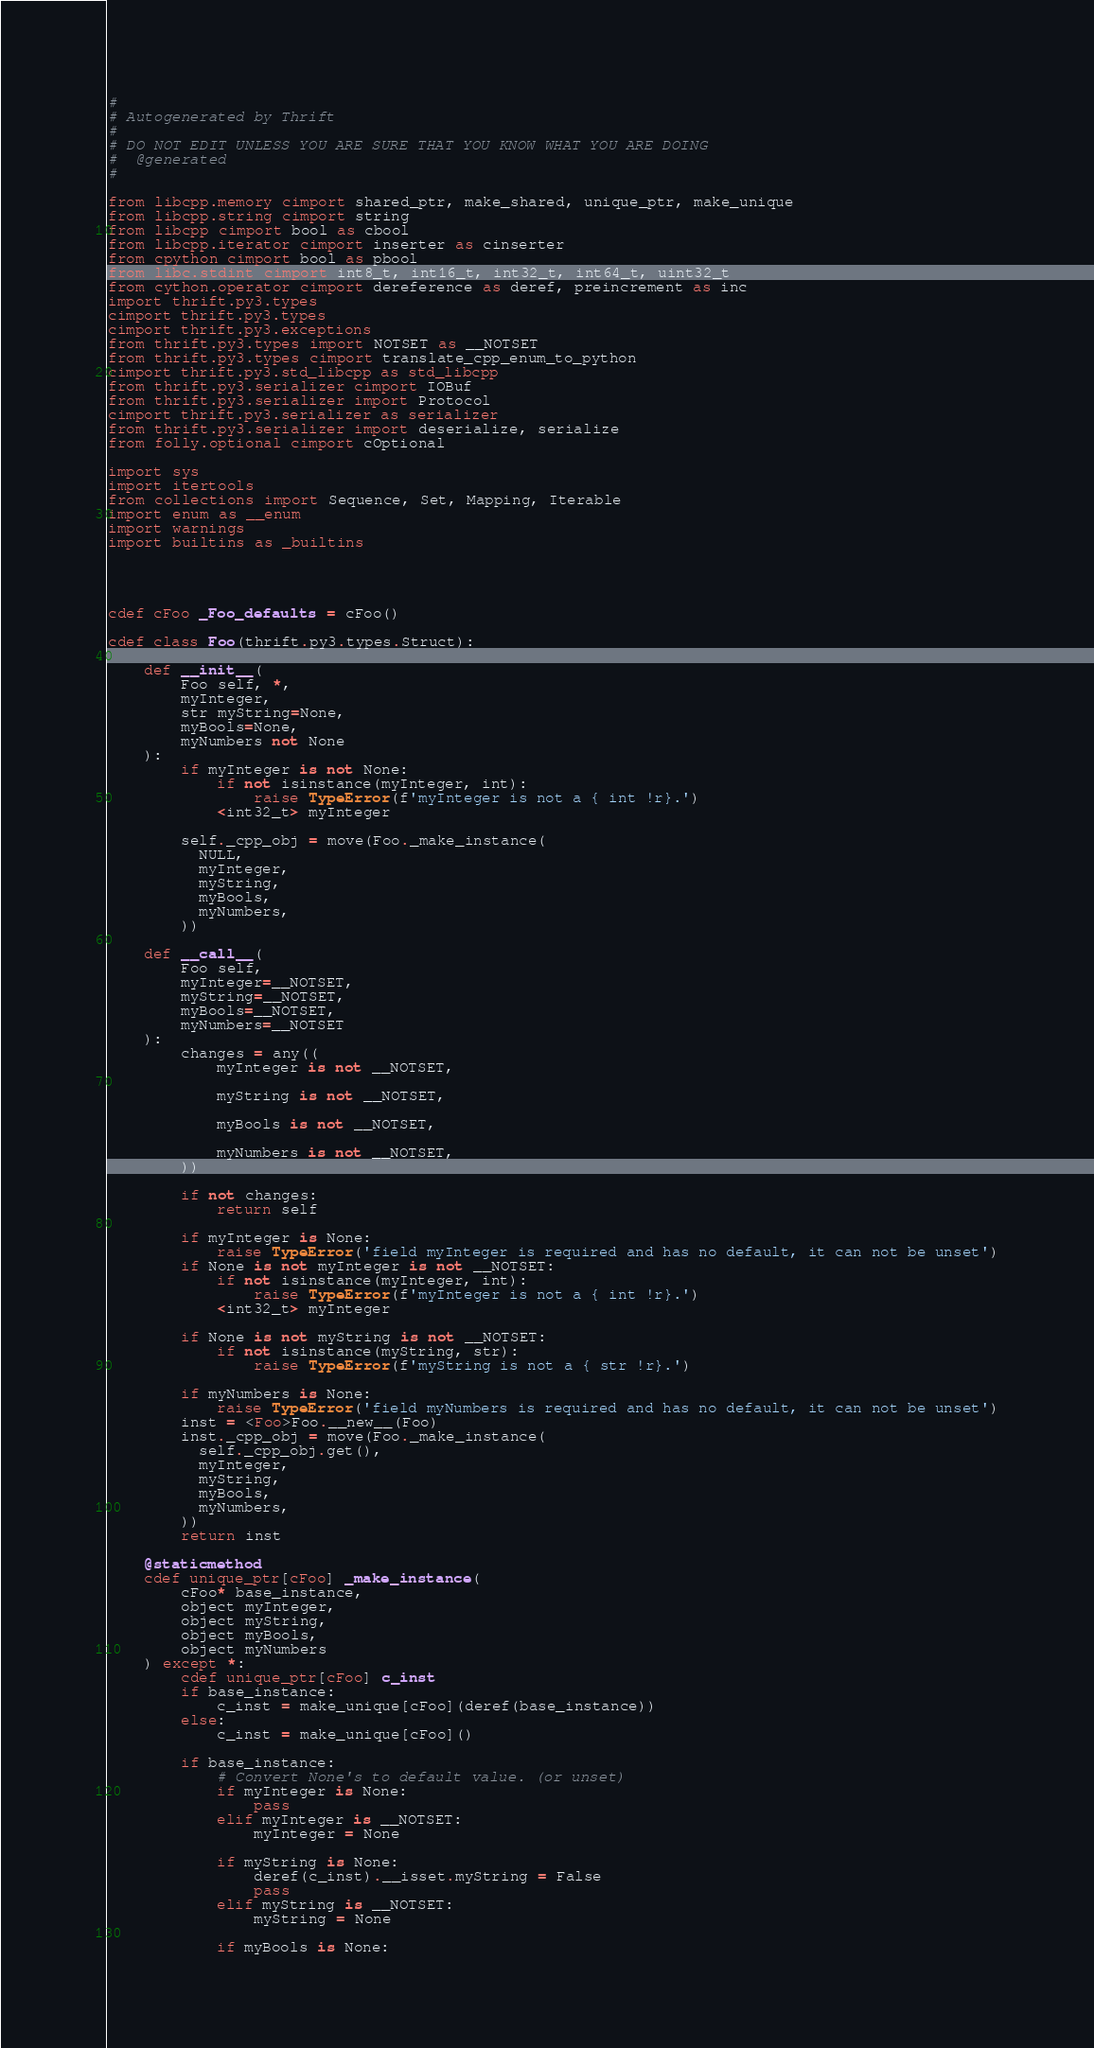<code> <loc_0><loc_0><loc_500><loc_500><_Cython_>#
# Autogenerated by Thrift
#
# DO NOT EDIT UNLESS YOU ARE SURE THAT YOU KNOW WHAT YOU ARE DOING
#  @generated
#

from libcpp.memory cimport shared_ptr, make_shared, unique_ptr, make_unique
from libcpp.string cimport string
from libcpp cimport bool as cbool
from libcpp.iterator cimport inserter as cinserter
from cpython cimport bool as pbool
from libc.stdint cimport int8_t, int16_t, int32_t, int64_t, uint32_t
from cython.operator cimport dereference as deref, preincrement as inc
import thrift.py3.types
cimport thrift.py3.types
cimport thrift.py3.exceptions
from thrift.py3.types import NOTSET as __NOTSET
from thrift.py3.types cimport translate_cpp_enum_to_python
cimport thrift.py3.std_libcpp as std_libcpp
from thrift.py3.serializer cimport IOBuf
from thrift.py3.serializer import Protocol
cimport thrift.py3.serializer as serializer
from thrift.py3.serializer import deserialize, serialize
from folly.optional cimport cOptional

import sys
import itertools
from collections import Sequence, Set, Mapping, Iterable
import enum as __enum
import warnings
import builtins as _builtins




cdef cFoo _Foo_defaults = cFoo()

cdef class Foo(thrift.py3.types.Struct):

    def __init__(
        Foo self, *,
        myInteger,
        str myString=None,
        myBools=None,
        myNumbers not None
    ):
        if myInteger is not None:
            if not isinstance(myInteger, int):
                raise TypeError(f'myInteger is not a { int !r}.')
            <int32_t> myInteger

        self._cpp_obj = move(Foo._make_instance(
          NULL,
          myInteger,
          myString,
          myBools,
          myNumbers,
        ))

    def __call__(
        Foo self,
        myInteger=__NOTSET,
        myString=__NOTSET,
        myBools=__NOTSET,
        myNumbers=__NOTSET
    ):
        changes = any((
            myInteger is not __NOTSET,

            myString is not __NOTSET,

            myBools is not __NOTSET,

            myNumbers is not __NOTSET,
        ))

        if not changes:
            return self

        if myInteger is None:
            raise TypeError('field myInteger is required and has no default, it can not be unset')
        if None is not myInteger is not __NOTSET:
            if not isinstance(myInteger, int):
                raise TypeError(f'myInteger is not a { int !r}.')
            <int32_t> myInteger

        if None is not myString is not __NOTSET:
            if not isinstance(myString, str):
                raise TypeError(f'myString is not a { str !r}.')

        if myNumbers is None:
            raise TypeError('field myNumbers is required and has no default, it can not be unset')
        inst = <Foo>Foo.__new__(Foo)
        inst._cpp_obj = move(Foo._make_instance(
          self._cpp_obj.get(),
          myInteger,
          myString,
          myBools,
          myNumbers,
        ))
        return inst

    @staticmethod
    cdef unique_ptr[cFoo] _make_instance(
        cFoo* base_instance,
        object myInteger,
        object myString,
        object myBools,
        object myNumbers
    ) except *:
        cdef unique_ptr[cFoo] c_inst
        if base_instance:
            c_inst = make_unique[cFoo](deref(base_instance))
        else:
            c_inst = make_unique[cFoo]()

        if base_instance:
            # Convert None's to default value. (or unset)
            if myInteger is None:
                pass
            elif myInteger is __NOTSET:
                myInteger = None

            if myString is None:
                deref(c_inst).__isset.myString = False
                pass
            elif myString is __NOTSET:
                myString = None

            if myBools is None:</code> 